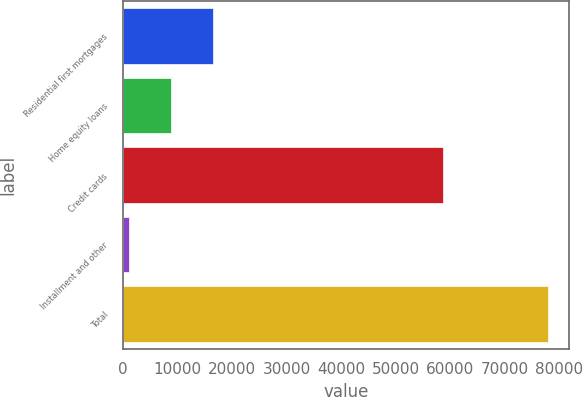Convert chart. <chart><loc_0><loc_0><loc_500><loc_500><bar_chart><fcel>Residential first mortgages<fcel>Home equity loans<fcel>Credit cards<fcel>Installment and other<fcel>Total<nl><fcel>16470.2<fcel>8783.6<fcel>58722<fcel>1097<fcel>77963<nl></chart> 